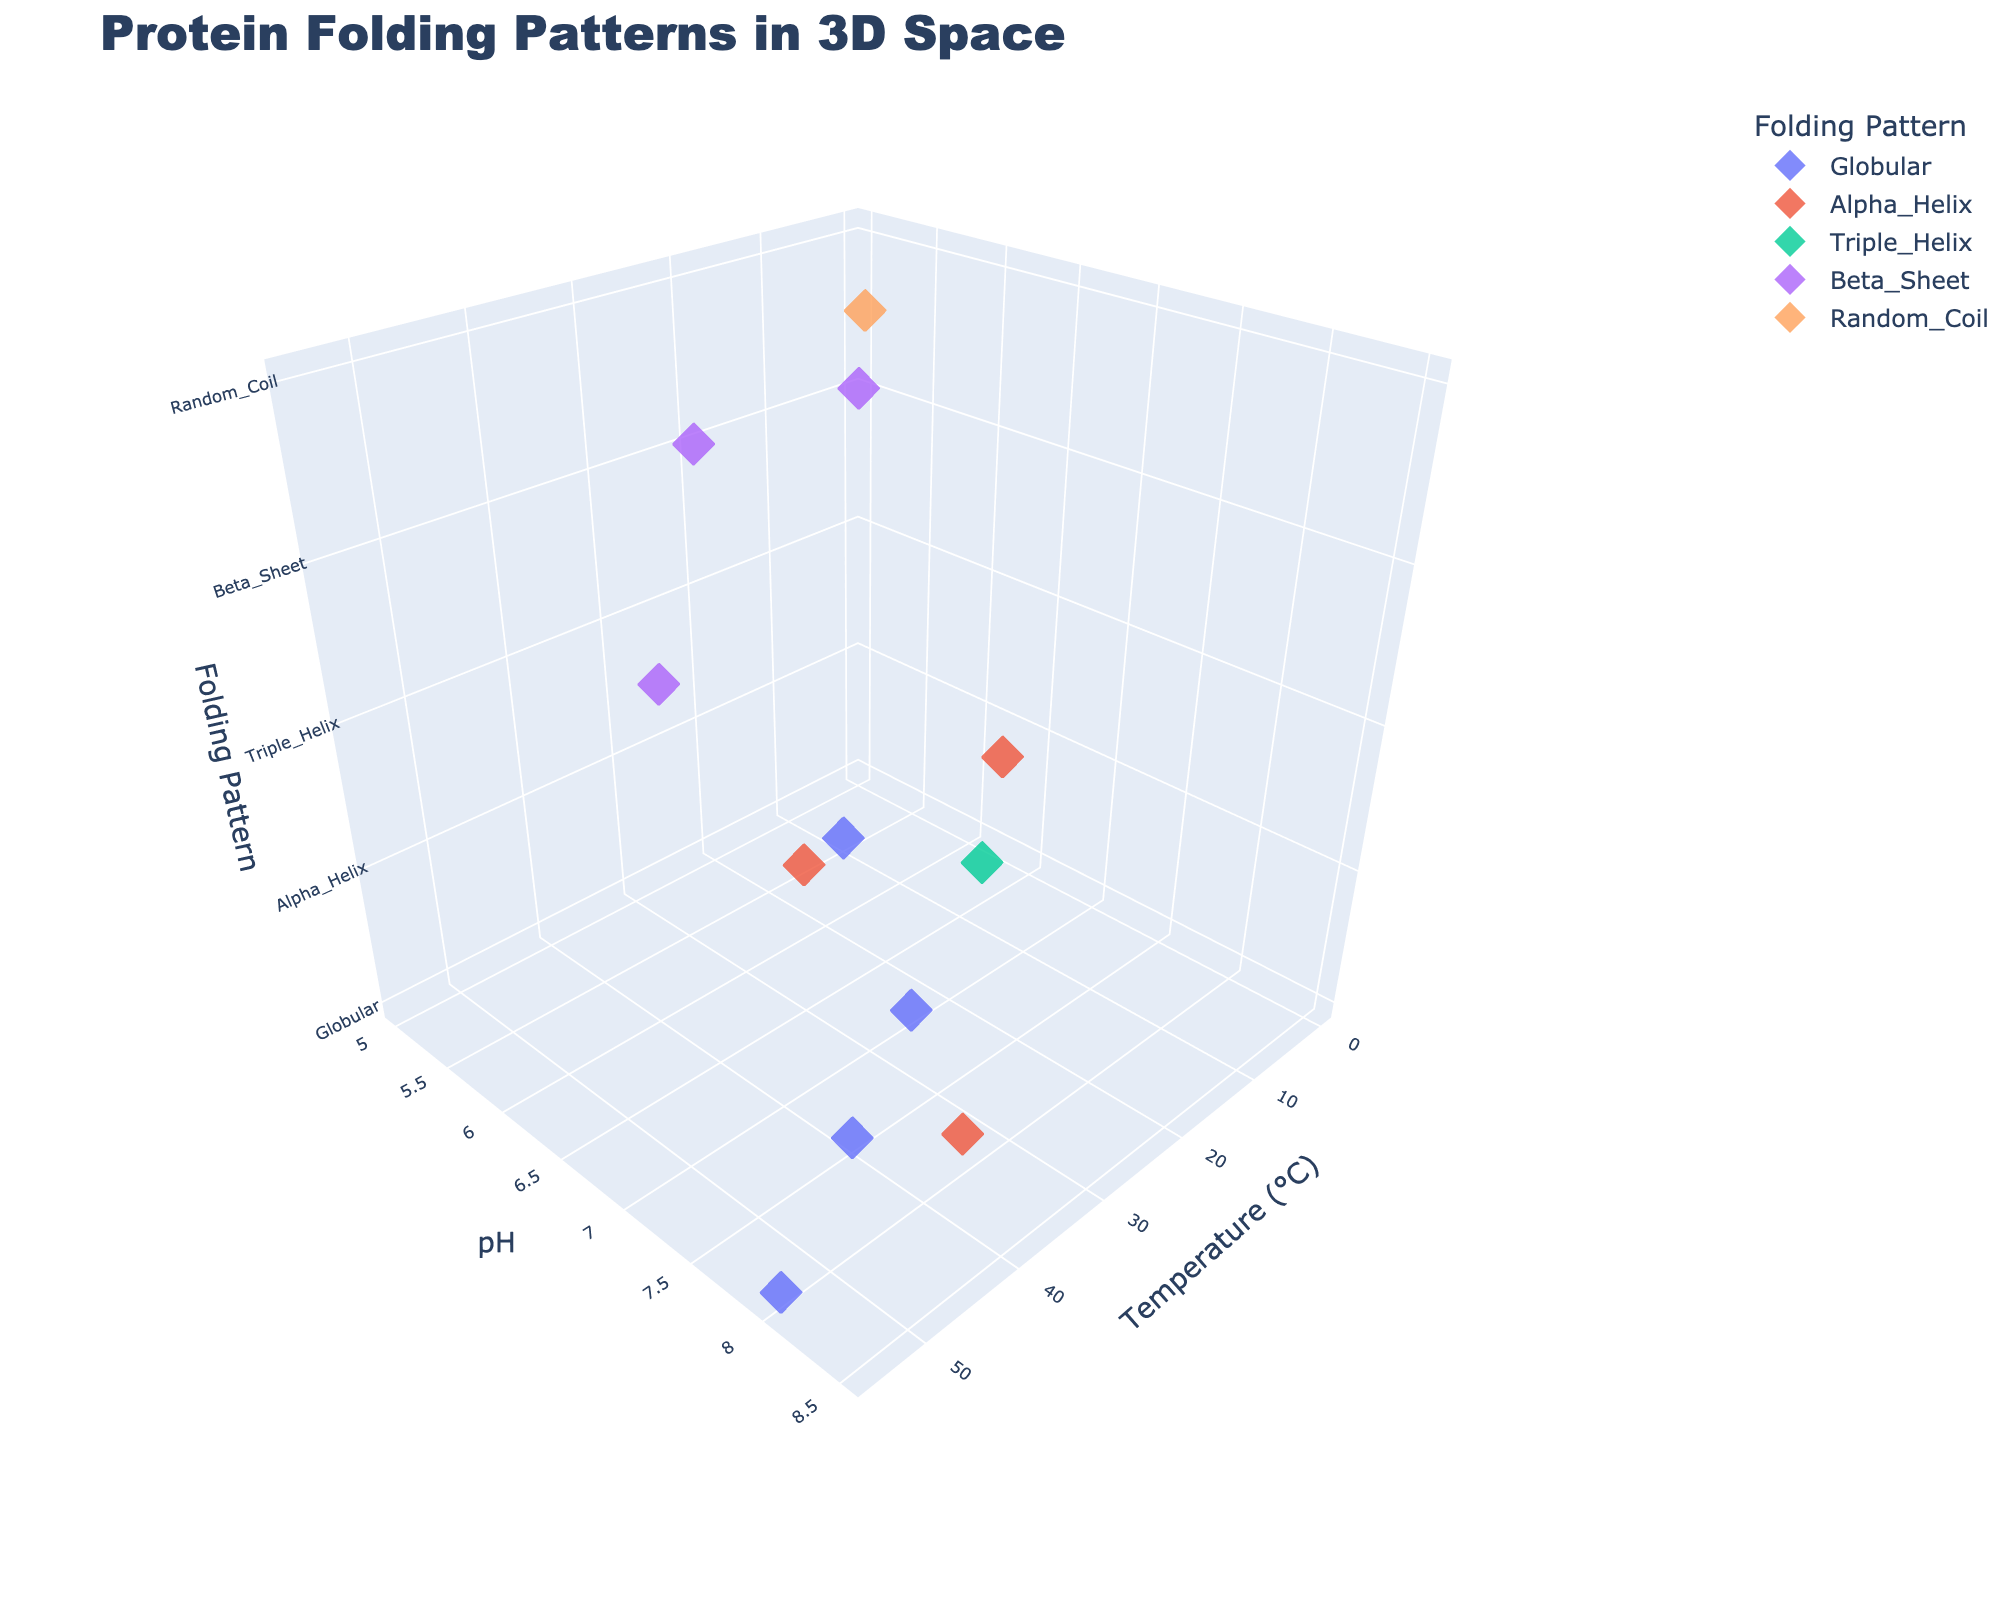What's the title of the figure? The title is usually found at the top of the figure in a larger or bold font. In this case, it's specified in the `update_layout` function.
Answer: Protein Folding Patterns in 3D Space How many unique folding patterns are shown? The number of unique folding patterns is specified by the `folding_patterns` variable, which lists and differentiates the various patterns. These are: Globular, Alpha_Helix, Triple_Helix, Beta_Sheet, Random_Coil.
Answer: 5 What is the folding pattern of Lysozyme at 25°C and pH 7? The folding pattern can be found from the data point at 25°C and pH 7. By checking the provided data, Lysozyme corresponds to the "Globular" folding pattern.
Answer: Globular Which protein exhibits a Triple_Helix folding pattern? Identifying the folding pattern related to `Triple_Helix`, we can refer to the provided data to find which protein corresponds to this pattern. From the data, Collagen displays a Triple_Helix folding pattern at 35°C and pH 8.
Answer: Collagen Which folding pattern appears at the highest temperature? To find the folding pattern at the highest temperature, consider the provided data point with the highest temperature, 55°C. Albumin is the protein at this temperature, and its folding pattern is Globular.
Answer: Globular Which protein shares the same folding pattern as Actin? Looking at Actin’s folding pattern in the data, which is Globular, we find other proteins with the same pattern. By examining the list, the proteins sharing the Globular pattern include Lysozyme, Myoglobin, and Albumin.
Answer: Lysozyme, Myoglobin, Albumin How does the folding pattern of proteins change with increasing temperature? This requires observing the provided data points and noting the folding patterns linked to increasing temperature values. From lower to higher temperatures (0°C to 55°C), the patterns include Beta_Sheet, Globular, Alpha_Helix, Triple_Helix, Beta_Sheet, Globular, Alpha_Helix, Globular. This shows a varying sequence without a simple trend.
Answer: Varying sequence What is the average temperature at which the Alpha_Helix folding pattern is observed? Calculate the average of the temperatures corresponding to Alpha_Helix: 30, 45, 5. Sum these temperatures (30 + 45 + 5 = 80) and divide by the number of observations (80/3).
Answer: 26.67°C Between which pH levels do proteins exhibit a Beta_Sheet folding pattern? Examine the `pH` values in the data points associated with `Beta_Sheet`. These include 5, 7.5, and 5.5. Hence, pH ranges from 5 to 7.5.
Answer: 5 to 7.5 What is the folding pattern of proteins at pH levels below 6? Identify proteins at pH levels below 6 and note their folding patterns. Data points with pH < 6 include Keratin (Beta_Sheet), Elastin (Random_Coil), Actin (Globular), and Amylase (Beta_Sheet).
Answer: Beta_Sheet, Random_Coil, Globular 